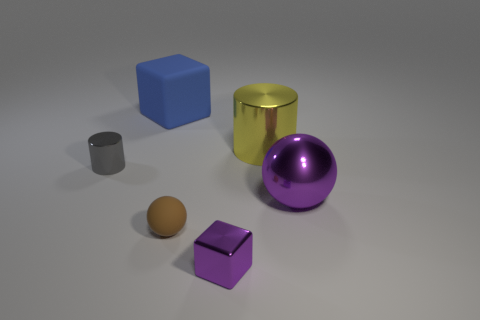What number of red things are there?
Offer a very short reply. 0. The thing that is the same color as the metallic block is what shape?
Provide a succinct answer. Sphere. The yellow object that is the same shape as the gray object is what size?
Offer a terse response. Large. Does the brown object in front of the big cylinder have the same shape as the large purple thing?
Your answer should be compact. Yes. There is a object that is in front of the small matte thing; what is its color?
Make the answer very short. Purple. Is the number of small purple metallic things in front of the tiny shiny cube the same as the number of tiny balls?
Offer a very short reply. No. How many other large yellow objects have the same material as the yellow object?
Offer a very short reply. 0. What is the color of the ball that is made of the same material as the small purple thing?
Offer a terse response. Purple. Is the gray metal object the same shape as the yellow metal object?
Offer a terse response. Yes. Are there any things in front of the cylinder to the right of the block in front of the rubber cube?
Offer a terse response. Yes. 